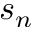<formula> <loc_0><loc_0><loc_500><loc_500>s _ { n }</formula> 